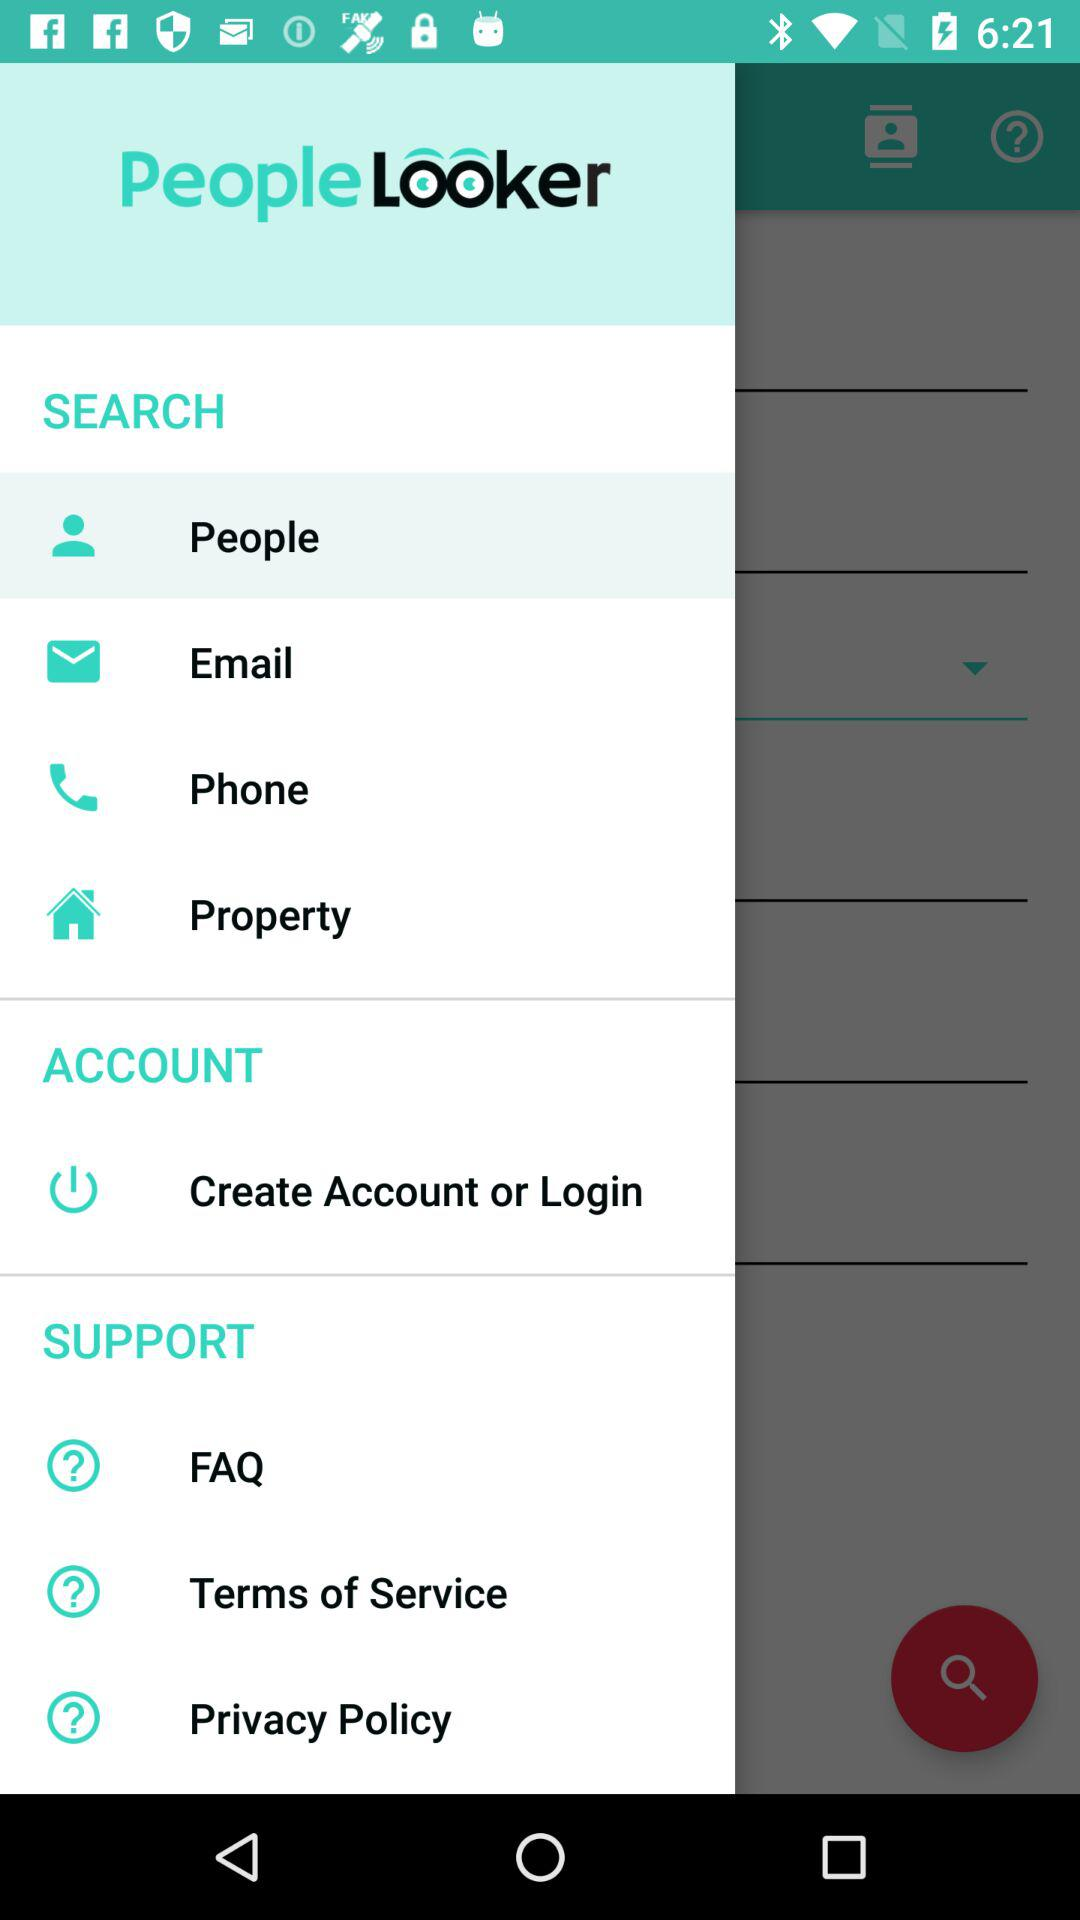Which email address is used for the account?
When the provided information is insufficient, respond with <no answer>. <no answer> 